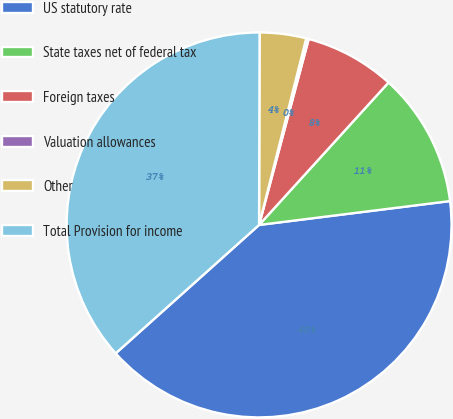<chart> <loc_0><loc_0><loc_500><loc_500><pie_chart><fcel>US statutory rate<fcel>State taxes net of federal tax<fcel>Foreign taxes<fcel>Valuation allowances<fcel>Other<fcel>Total Provision for income<nl><fcel>40.36%<fcel>11.28%<fcel>7.59%<fcel>0.21%<fcel>3.9%<fcel>36.67%<nl></chart> 